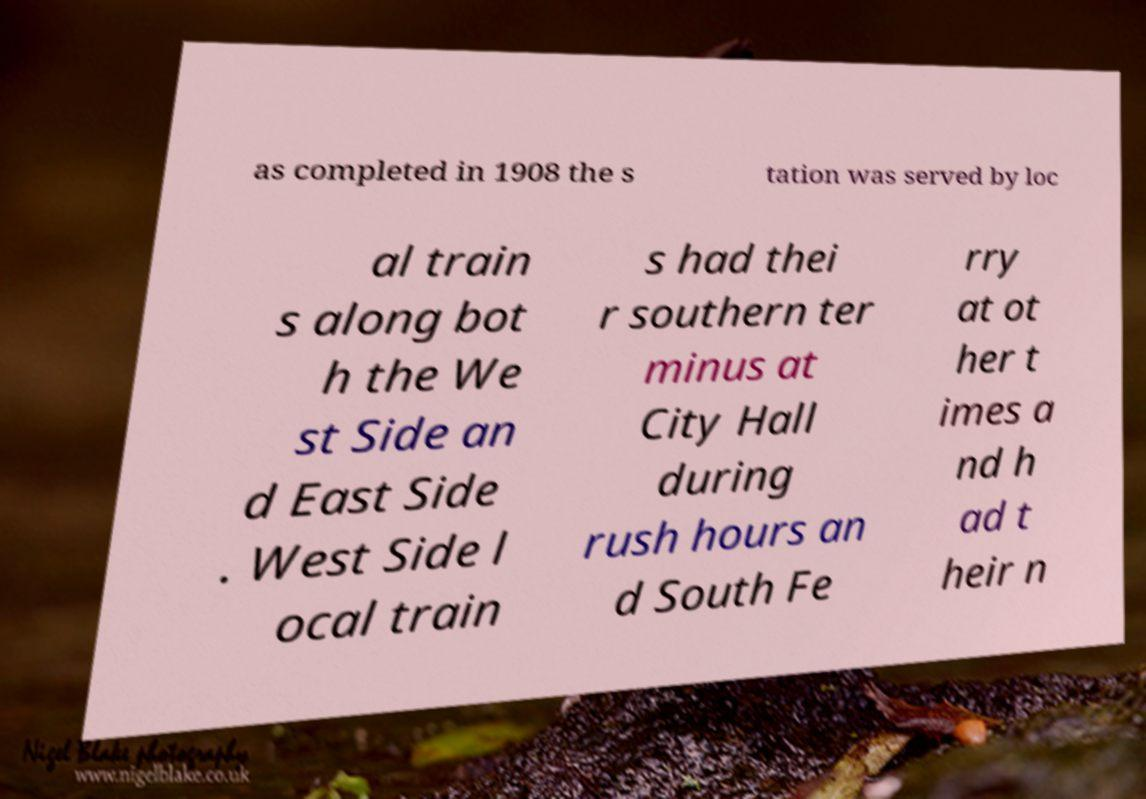Could you extract and type out the text from this image? as completed in 1908 the s tation was served by loc al train s along bot h the We st Side an d East Side . West Side l ocal train s had thei r southern ter minus at City Hall during rush hours an d South Fe rry at ot her t imes a nd h ad t heir n 